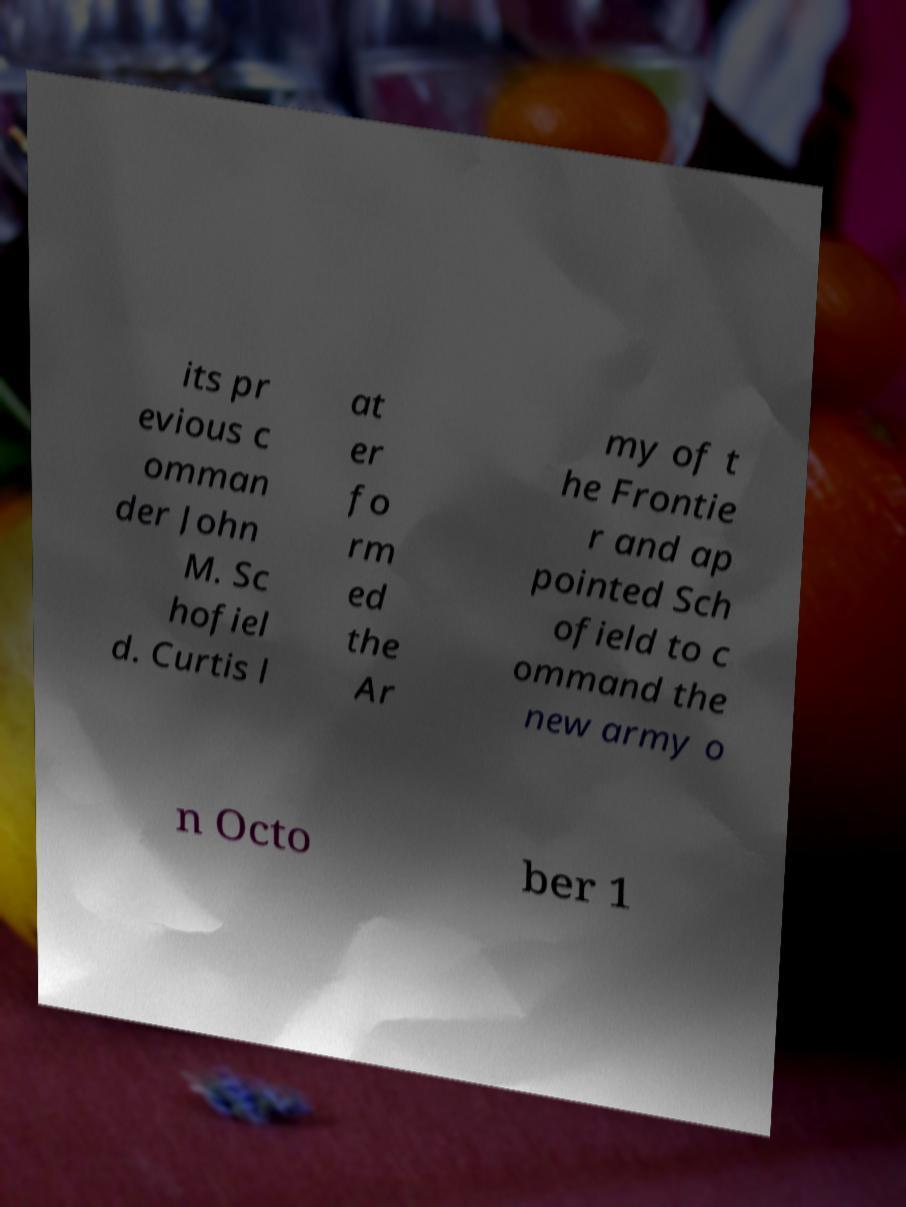For documentation purposes, I need the text within this image transcribed. Could you provide that? The text within the image appears to discuss historical military context, mentioning a commander named John M. Schofield. Unfortunately, the photo is too blurry, and some words are obscured and disconnected. These factors make it challenging to provide a complete and accurate transcription without speculations or omissions. 